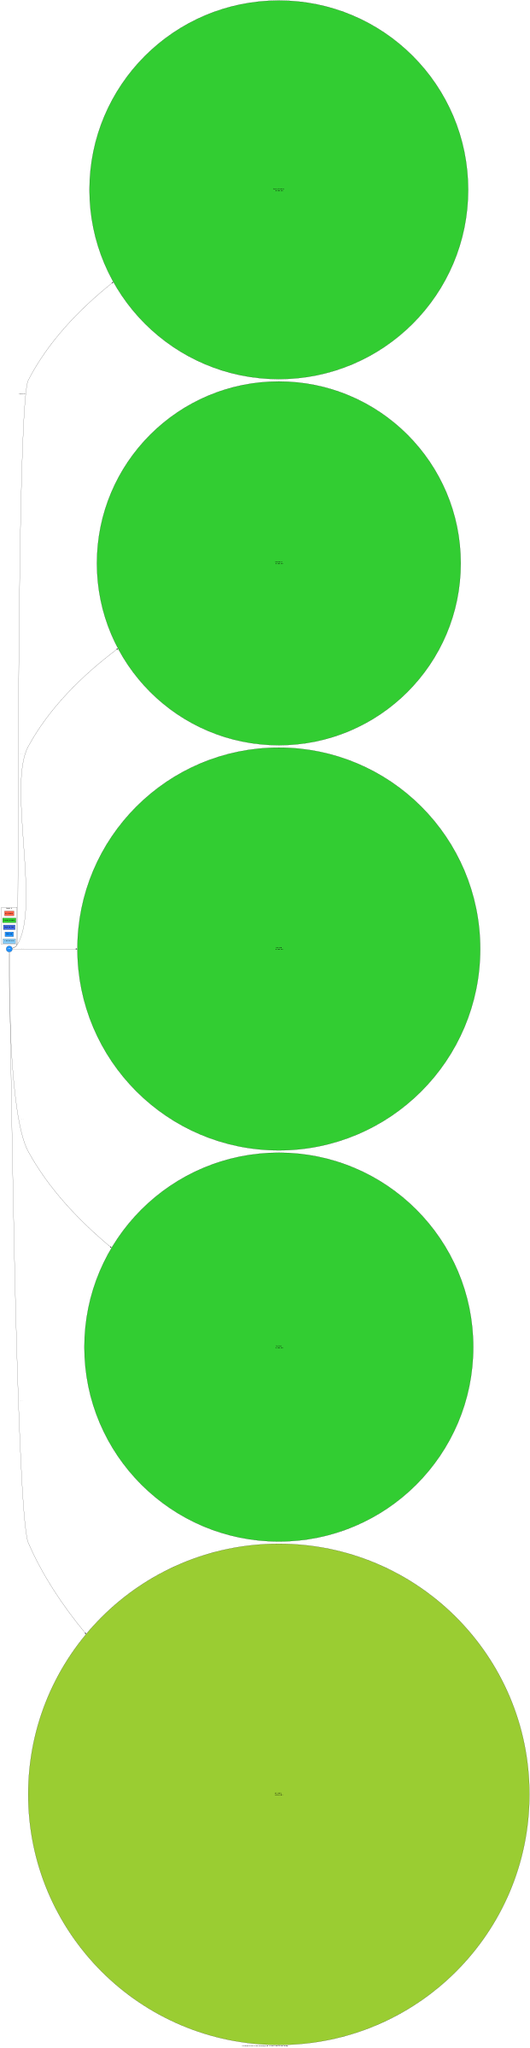What is the closest exoplanet to Earth? The closest exoplanet listed in the diagram is Proxima Centauri b, which is located 4.2 light-years away from Earth.
Answer: Proxima Centauri b How many exoplanets are potentially habitable? The diagram indicates that there are four exoplanets considered potentially habitable: Proxima Centauri b, TRAPPIST-1e, TOI-700 d, and HD 40307 g.
Answer: Four What is the size of HD 40307 g in relation to Earth? HD 40307 g is noted as having a size of 2.4 Earth radii, indicating it is larger than Earth.
Answer: 2.4 Earth radii Which exoplanet is the largest according to the diagram? The largest exoplanet shown in the diagram is HD 40307 g, with a size of 2.4 Earth radii.
Answer: HD 40307 g What is the distance of TOI-700 d from Earth? The diagram specifies that TOI-700 d is located 101.4 light-years away from Earth.
Answer: 101.4 light-years Which exoplanet is furthest from Earth? Kepler-442b is listed as being 1,206 light-years away, making it the furthest exoplanet shown in the diagram.
Answer: Kepler-442b How many exoplanets are larger than Earth? The diagram shows two exoplanets that are larger than Earth: HD 40307 g and Kepler-442b.
Answer: Two What color represents potentially habitable exoplanets in the diagram? Potentially habitable exoplanets are represented by a green color, specifically #32CD32 in the diagram's legend.
Answer: Green How many light-years away is TRAPPIST-1e from Earth? TRAPPIST-1e is indicated to be 39 light-years away from Earth in the diagram.
Answer: 39 light-years 